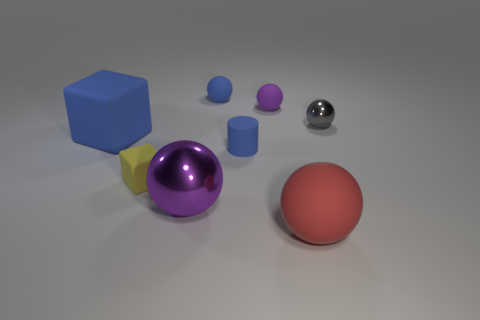Which object in the image appears to have the smoothest surface? The small metal sphere has the smoothest surface, reflecting its surroundings with a high gloss finish. How can you tell it's the smoothest? The smoothness of an object's surface is often indicated by the way it reflects light and the environment. The metal sphere shows clear reflections and lacks any visible texture, suggesting a very smooth surface. 